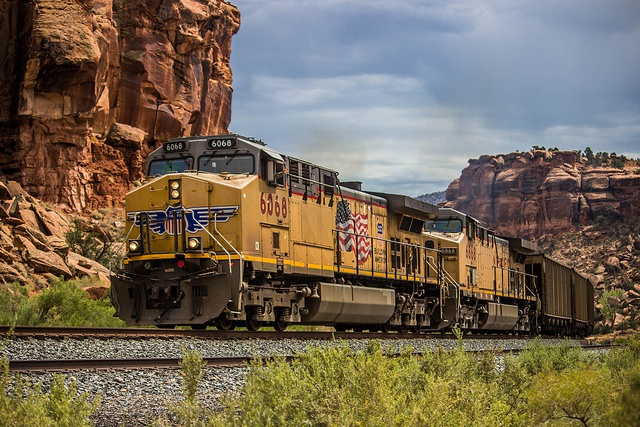Describe the objects in this image and their specific colors. I can see a train in black, maroon, and tan tones in this image. 